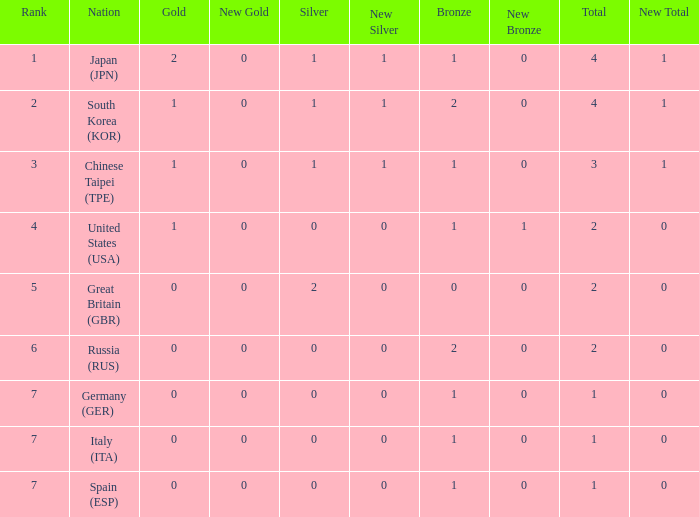How many total medals does a country with more than 1 silver medals have? 2.0. 